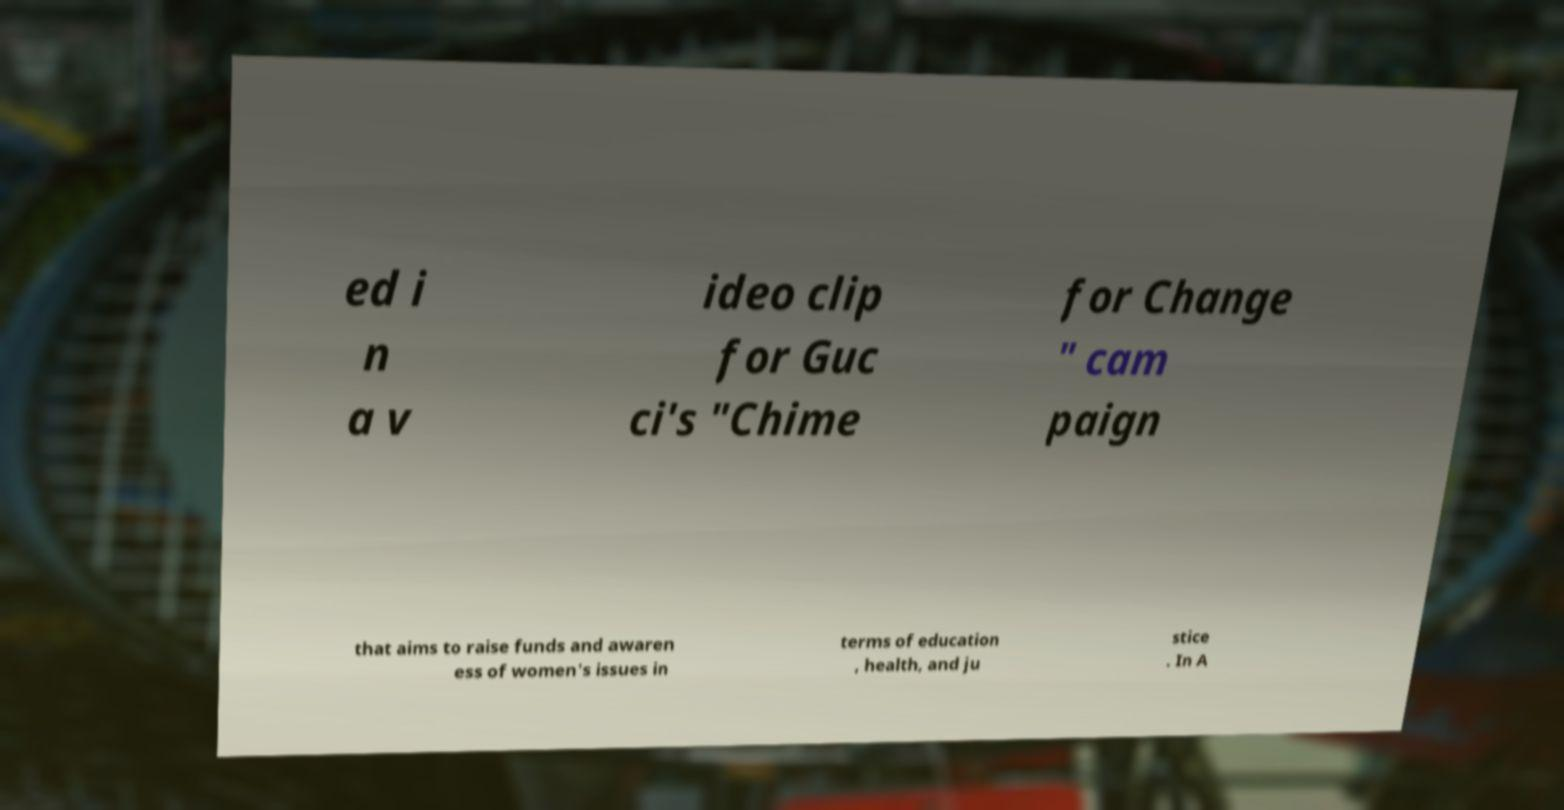Could you extract and type out the text from this image? ed i n a v ideo clip for Guc ci's "Chime for Change " cam paign that aims to raise funds and awaren ess of women's issues in terms of education , health, and ju stice . In A 